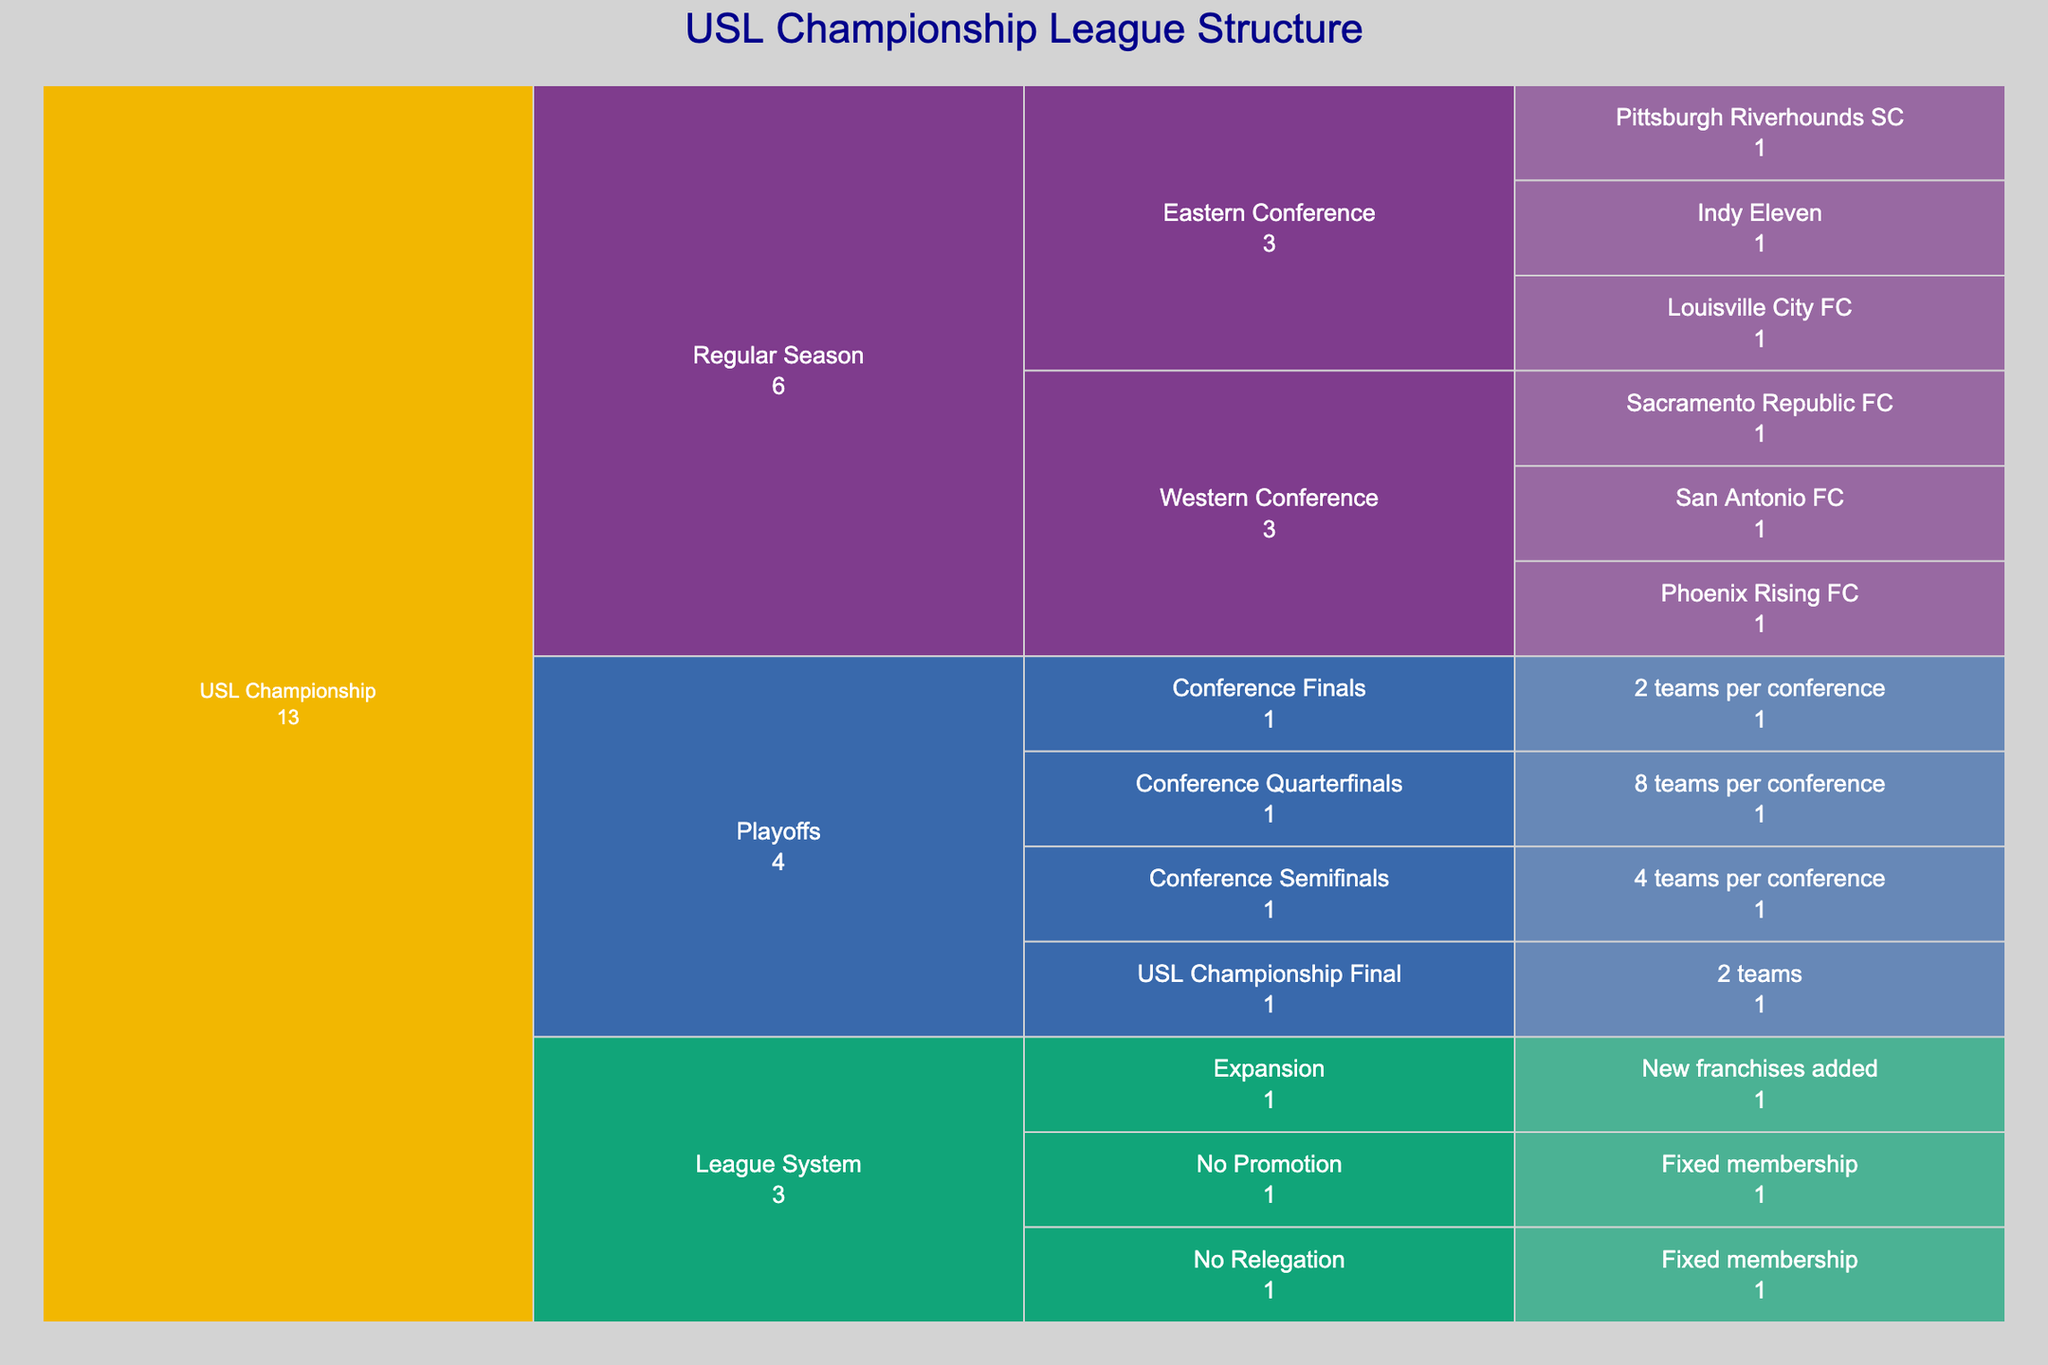How many divisions are there in the USL Championship as per the chart? The chart shows hierarchical paths with different levels. By examining the first level under "USL Championship", you can count how many unique division labels appear.
Answer: 3 How many teams are displayed just under the "Western Conference" in the Regular Season? By following the path from "USL Championship" to "Regular Season" then "Western Conference", you will see the individual team names. Counting these names gives the number of teams.
Answer: 3 What is the color used for the "Playoffs" division in the chart? The colors of the divisions are shown in the legend of the chart or can be visually distinguished. Locate the "Playoffs" section and identify its color.
Answer: [Color to be determined by visual inspection; assume a color like Blue] How many teams are involved at each stage of the Playoffs? Follow the hierarchical structure under the "Playoffs" division to see the number of teams listed at each stage: Conference Quarterfinals, Conference Semifinals, Conference Finals, and USL Championship Final.
Answer: 8 teams per conference in Quarterfinals, 4 teams per conference in Semifinals, 2 teams per conference in Conference Finals, and 2 teams in the Championship Final Which conference has the Indy Eleven team? Navigate through the hierarchy: "USL Championship" -> "Regular Season" -> "Eastern Conference", and observe which teams are listed under "Eastern Conference".
Answer: Eastern Conference If a new team were to be added to a conference, which section of the chart explains this process? The bottom part of the hierarchy under "League System" explains sections like "No Promotion", "No Relegation", and "Expansion" which detail the league's framework. The "Expansion" node would explain the process of adding new teams.
Answer: Expansion Is there a promotion/relegation system in the USL Championship according to the chart? Look under the "League System" division for labels related to promotion and relegation. The labels "No Promotion" and "No Relegation" indicate the absence of such a system.
Answer: No How many teams are shown in total in the Regular Season under both conferences? Sum the total number of teams under both "Eastern Conference" and "Western Conference" in the "Regular Season" division.
Answer: 6 (3 in Eastern and 3 in Western) Which division has a fixed membership according to the chart? The section under "League System" will provide this information, specifically under "No Promotion" and "No Relegation" which indicate fixed membership.
Answer: Regular Season 